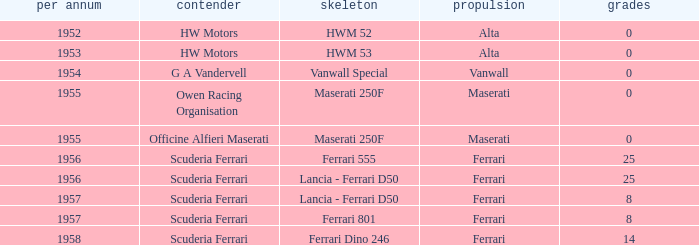What company made the chassis when Ferrari made the engine and there were 25 points? Ferrari 555, Lancia - Ferrari D50. 